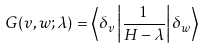<formula> <loc_0><loc_0><loc_500><loc_500>G ( v , w ; \lambda ) = \left \langle \delta _ { v } \left | { \frac { 1 } { H - \lambda } } \right | \delta _ { w } \right \rangle</formula> 